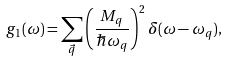Convert formula to latex. <formula><loc_0><loc_0><loc_500><loc_500>g _ { 1 } ( \omega ) = \sum _ { \vec { q } } \left ( \frac { M _ { q } } { \hbar { \omega } _ { q } } \right ) ^ { 2 } \delta ( \omega - \omega _ { q } ) ,</formula> 